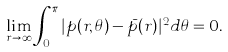Convert formula to latex. <formula><loc_0><loc_0><loc_500><loc_500>\lim _ { r \to \infty } \int _ { 0 } ^ { \pi } | p ( r , \theta ) - \bar { p } ( r ) | ^ { 2 } d \theta = 0 .</formula> 